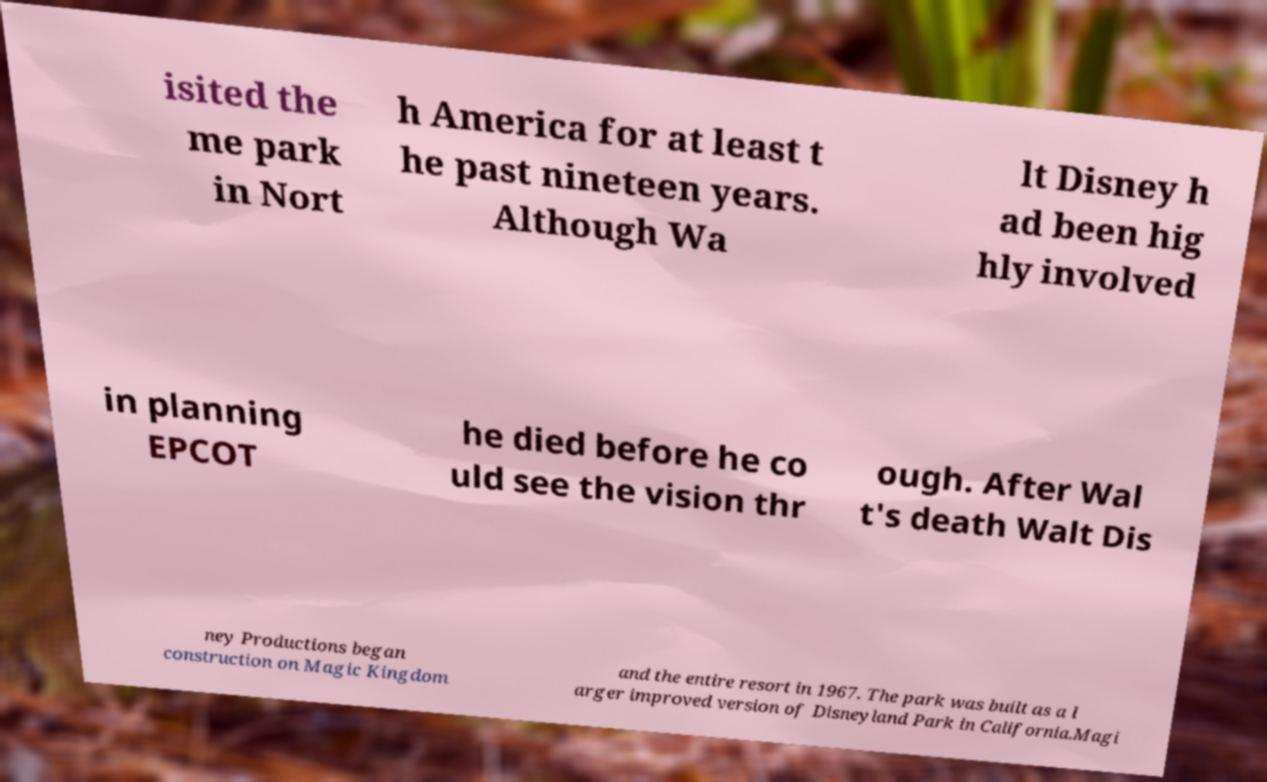There's text embedded in this image that I need extracted. Can you transcribe it verbatim? isited the me park in Nort h America for at least t he past nineteen years. Although Wa lt Disney h ad been hig hly involved in planning EPCOT he died before he co uld see the vision thr ough. After Wal t's death Walt Dis ney Productions began construction on Magic Kingdom and the entire resort in 1967. The park was built as a l arger improved version of Disneyland Park in California.Magi 